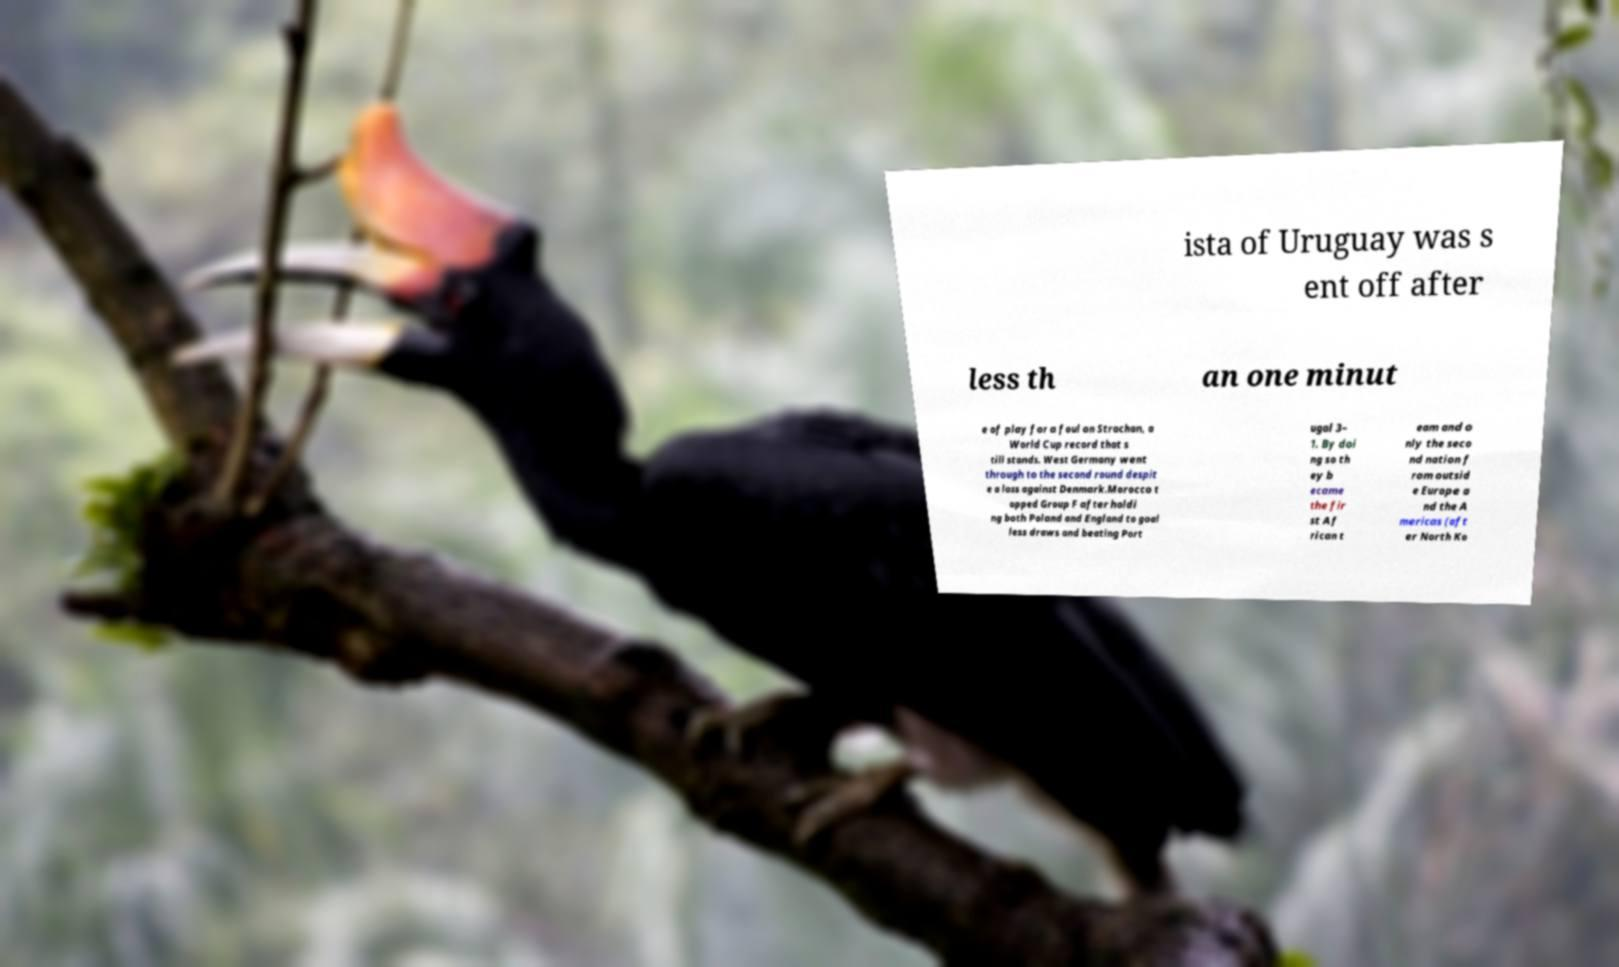Please identify and transcribe the text found in this image. ista of Uruguay was s ent off after less th an one minut e of play for a foul on Strachan, a World Cup record that s till stands. West Germany went through to the second round despit e a loss against Denmark.Morocco t opped Group F after holdi ng both Poland and England to goal less draws and beating Port ugal 3– 1. By doi ng so th ey b ecame the fir st Af rican t eam and o nly the seco nd nation f rom outsid e Europe a nd the A mericas (aft er North Ko 